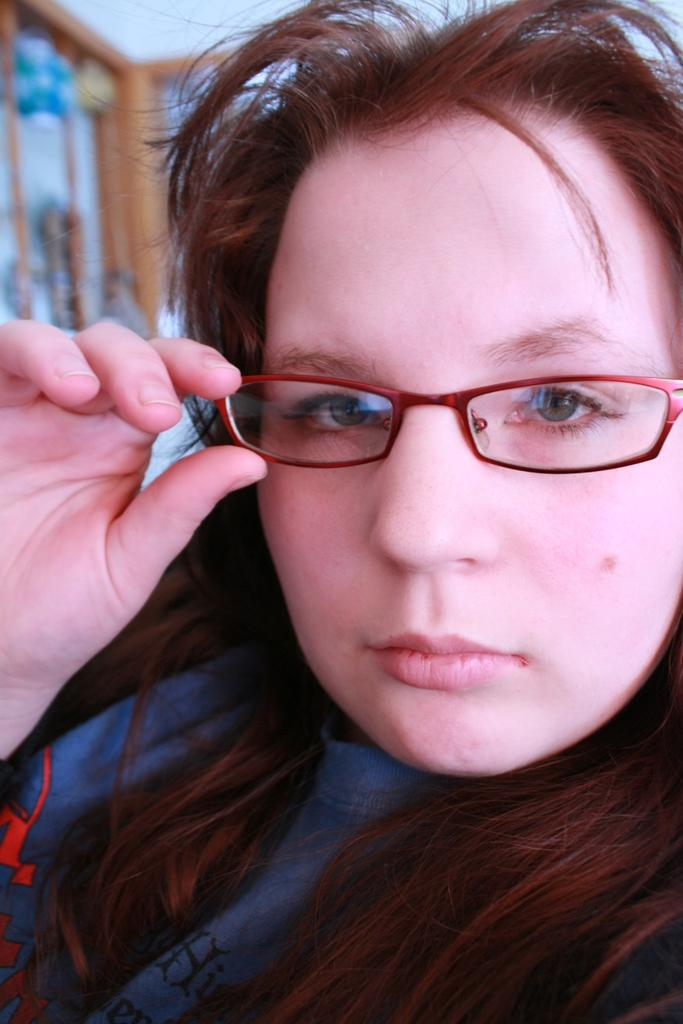Who is the main subject in the foreground of the image? There is a woman in the foreground of the image. What accessory is the woman wearing in the image? The woman is wearing spectacles in the image. What can be seen in the background of the image? There are objects in the background of the image. What type of liquid can be smelled in the image? There is no reference to any liquid or smell in the image, so it is not possible to determine what, if any, liquid might be smelled. 